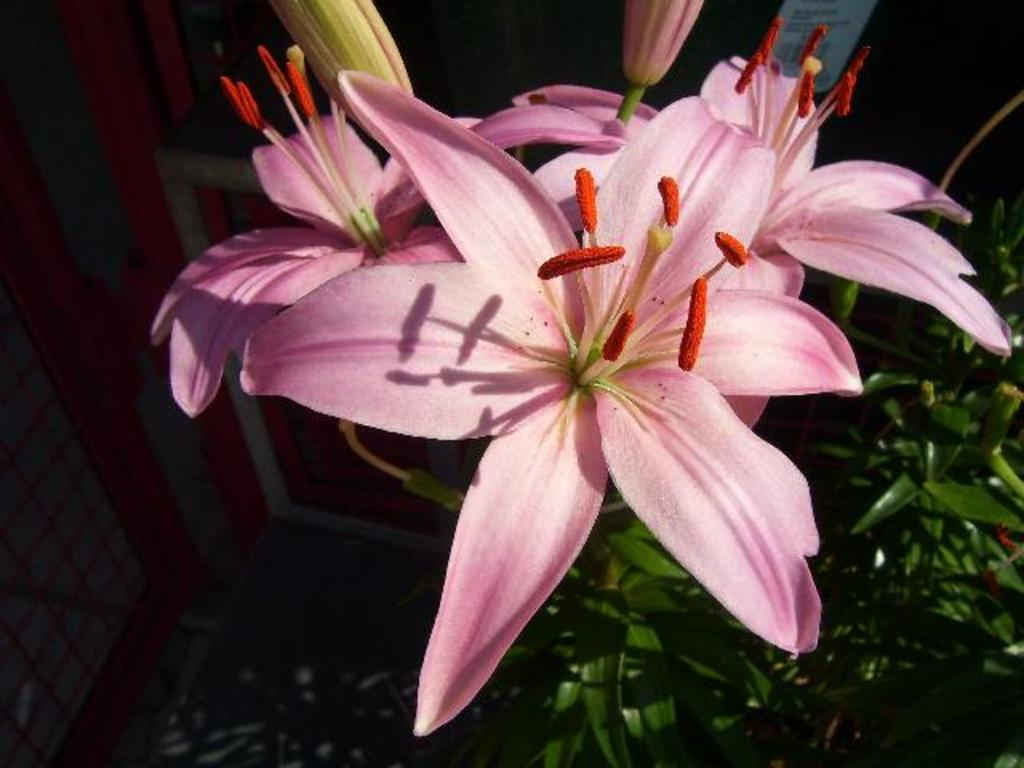What colors are the flowers in the image? The flowers in the image are in pink, orange, and green colors. What color are the plants in the image? The plants in the image are in green color. What can be seen in the background of the image? There are glass doors visible in the background of the image. Are there any dinosaurs present in the image? No, there are no dinosaurs present in the image. 